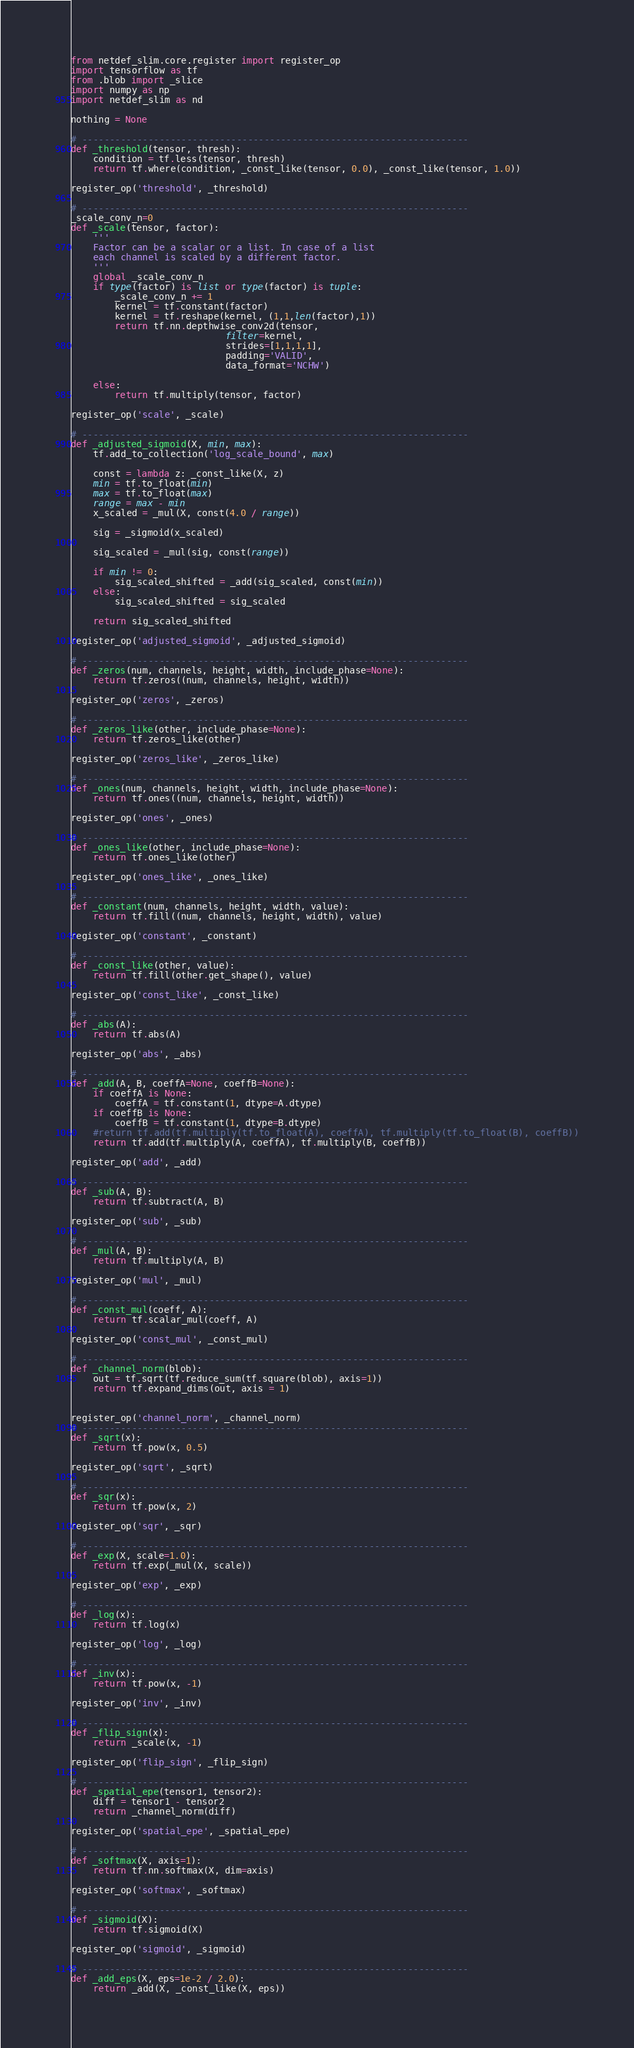<code> <loc_0><loc_0><loc_500><loc_500><_Python_>from netdef_slim.core.register import register_op
import tensorflow as tf
from .blob import _slice
import numpy as np
import netdef_slim as nd

nothing = None

# ----------------------------------------------------------------------
def _threshold(tensor, thresh):
    condition = tf.less(tensor, thresh)
    return tf.where(condition, _const_like(tensor, 0.0), _const_like(tensor, 1.0))

register_op('threshold', _threshold)

# ----------------------------------------------------------------------
_scale_conv_n=0
def _scale(tensor, factor):
    '''
    Factor can be a scalar or a list. In case of a list
    each channel is scaled by a different factor.
    '''
    global _scale_conv_n
    if type(factor) is list or type(factor) is tuple:
        _scale_conv_n += 1
        kernel = tf.constant(factor)
        kernel = tf.reshape(kernel, (1,1,len(factor),1))
        return tf.nn.depthwise_conv2d(tensor,
                            filter=kernel,
                            strides=[1,1,1,1],
                            padding='VALID',
                            data_format='NCHW')

    else:
        return tf.multiply(tensor, factor)

register_op('scale', _scale)

# ----------------------------------------------------------------------
def _adjusted_sigmoid(X, min, max):
    tf.add_to_collection('log_scale_bound', max)

    const = lambda z: _const_like(X, z)
    min = tf.to_float(min)
    max = tf.to_float(max)
    range = max - min
    x_scaled = _mul(X, const(4.0 / range))

    sig = _sigmoid(x_scaled)

    sig_scaled = _mul(sig, const(range))

    if min != 0:
        sig_scaled_shifted = _add(sig_scaled, const(min))
    else:
        sig_scaled_shifted = sig_scaled

    return sig_scaled_shifted

register_op('adjusted_sigmoid', _adjusted_sigmoid)

# ----------------------------------------------------------------------
def _zeros(num, channels, height, width, include_phase=None):
    return tf.zeros((num, channels, height, width))

register_op('zeros', _zeros)

# ----------------------------------------------------------------------
def _zeros_like(other, include_phase=None):
    return tf.zeros_like(other)

register_op('zeros_like', _zeros_like)

# ----------------------------------------------------------------------
def _ones(num, channels, height, width, include_phase=None):
    return tf.ones((num, channels, height, width))

register_op('ones', _ones)

# ----------------------------------------------------------------------
def _ones_like(other, include_phase=None):
    return tf.ones_like(other)

register_op('ones_like', _ones_like)

# ----------------------------------------------------------------------
def _constant(num, channels, height, width, value):
    return tf.fill((num, channels, height, width), value)

register_op('constant', _constant)

# ----------------------------------------------------------------------
def _const_like(other, value):
    return tf.fill(other.get_shape(), value)

register_op('const_like', _const_like)

# ----------------------------------------------------------------------
def _abs(A):
    return tf.abs(A)

register_op('abs', _abs)

# ----------------------------------------------------------------------
def _add(A, B, coeffA=None, coeffB=None):
    if coeffA is None:
        coeffA = tf.constant(1, dtype=A.dtype)
    if coeffB is None:
        coeffB = tf.constant(1, dtype=B.dtype)
    #return tf.add(tf.multiply(tf.to_float(A), coeffA), tf.multiply(tf.to_float(B), coeffB))
    return tf.add(tf.multiply(A, coeffA), tf.multiply(B, coeffB))

register_op('add', _add)

# ----------------------------------------------------------------------
def _sub(A, B):
    return tf.subtract(A, B)

register_op('sub', _sub)

# ----------------------------------------------------------------------
def _mul(A, B):
    return tf.multiply(A, B)

register_op('mul', _mul)

# ----------------------------------------------------------------------
def _const_mul(coeff, A):
    return tf.scalar_mul(coeff, A)

register_op('const_mul', _const_mul)

# ----------------------------------------------------------------------
def _channel_norm(blob):
    out = tf.sqrt(tf.reduce_sum(tf.square(blob), axis=1))
    return tf.expand_dims(out, axis = 1)


register_op('channel_norm', _channel_norm)
# ----------------------------------------------------------------------
def _sqrt(x):
    return tf.pow(x, 0.5)

register_op('sqrt', _sqrt)

# ----------------------------------------------------------------------
def _sqr(x):
    return tf.pow(x, 2)

register_op('sqr', _sqr)

# ----------------------------------------------------------------------
def _exp(X, scale=1.0):
    return tf.exp(_mul(X, scale))

register_op('exp', _exp)

# ----------------------------------------------------------------------
def _log(x):
    return tf.log(x)

register_op('log', _log)

# ----------------------------------------------------------------------
def _inv(x):
    return tf.pow(x, -1)

register_op('inv', _inv)

# ----------------------------------------------------------------------
def _flip_sign(x):
    return _scale(x, -1)

register_op('flip_sign', _flip_sign)

# ----------------------------------------------------------------------
def _spatial_epe(tensor1, tensor2):
    diff = tensor1 - tensor2
    return _channel_norm(diff)

register_op('spatial_epe', _spatial_epe)

# ----------------------------------------------------------------------
def _softmax(X, axis=1):
    return tf.nn.softmax(X, dim=axis)

register_op('softmax', _softmax)

# ----------------------------------------------------------------------
def _sigmoid(X):
    return tf.sigmoid(X)

register_op('sigmoid', _sigmoid)

# ----------------------------------------------------------------------
def _add_eps(X, eps=1e-2 / 2.0):
    return _add(X, _const_like(X, eps))
</code> 